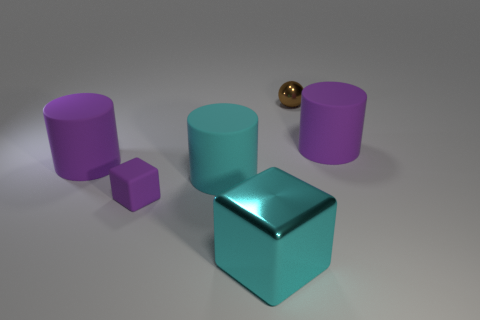The object that is in front of the cyan cylinder and behind the cyan metal thing is made of what material?
Your answer should be very brief. Rubber. What is the cyan cylinder made of?
Provide a succinct answer. Rubber. There is a cyan block that is the same size as the cyan cylinder; what is it made of?
Ensure brevity in your answer.  Metal. How many objects are small green rubber cylinders or rubber cylinders behind the big cyan cylinder?
Provide a short and direct response. 2. What size is the thing that is made of the same material as the cyan cube?
Your answer should be very brief. Small. What shape is the big purple matte object that is to the right of the large purple object that is on the left side of the cyan cylinder?
Give a very brief answer. Cylinder. There is a thing that is both in front of the cyan matte object and left of the large cyan rubber cylinder; how big is it?
Provide a succinct answer. Small. Are there any yellow things of the same shape as the cyan metallic thing?
Offer a terse response. No. Are there any other things that are the same shape as the tiny shiny thing?
Your answer should be very brief. No. The big object that is in front of the small purple object left of the purple rubber cylinder right of the small brown metallic ball is made of what material?
Make the answer very short. Metal. 